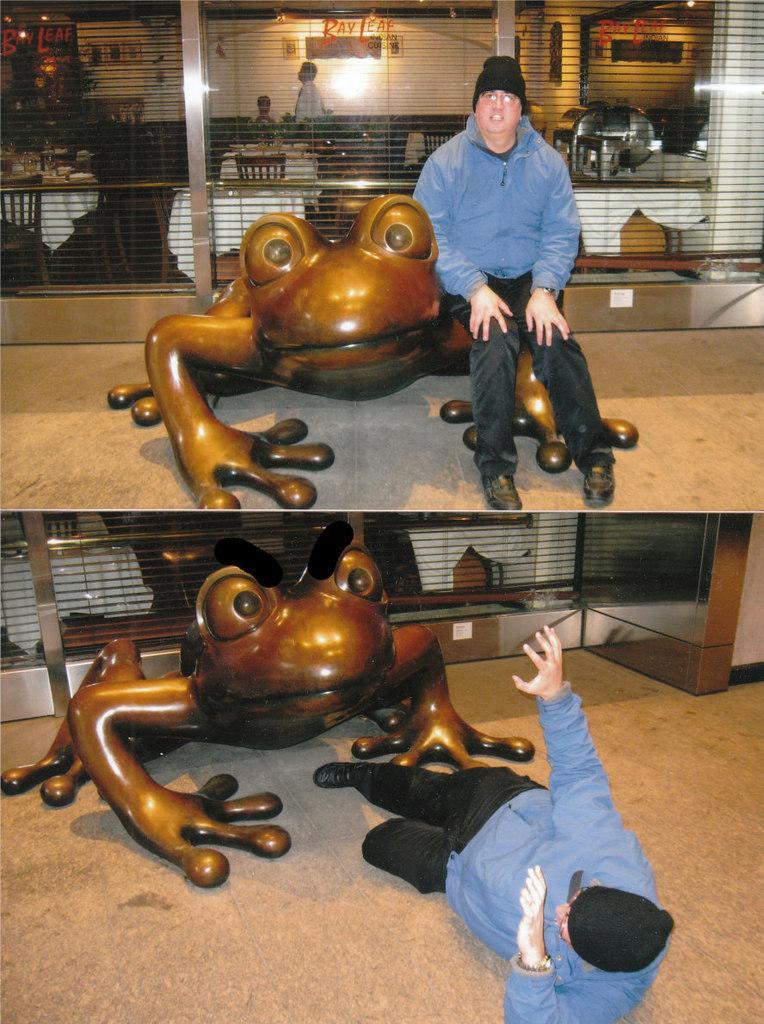Please provide a concise description of this image. This image is a collage picture. In this image I can see people, chairs, tables, and wall, lights and other objects. 